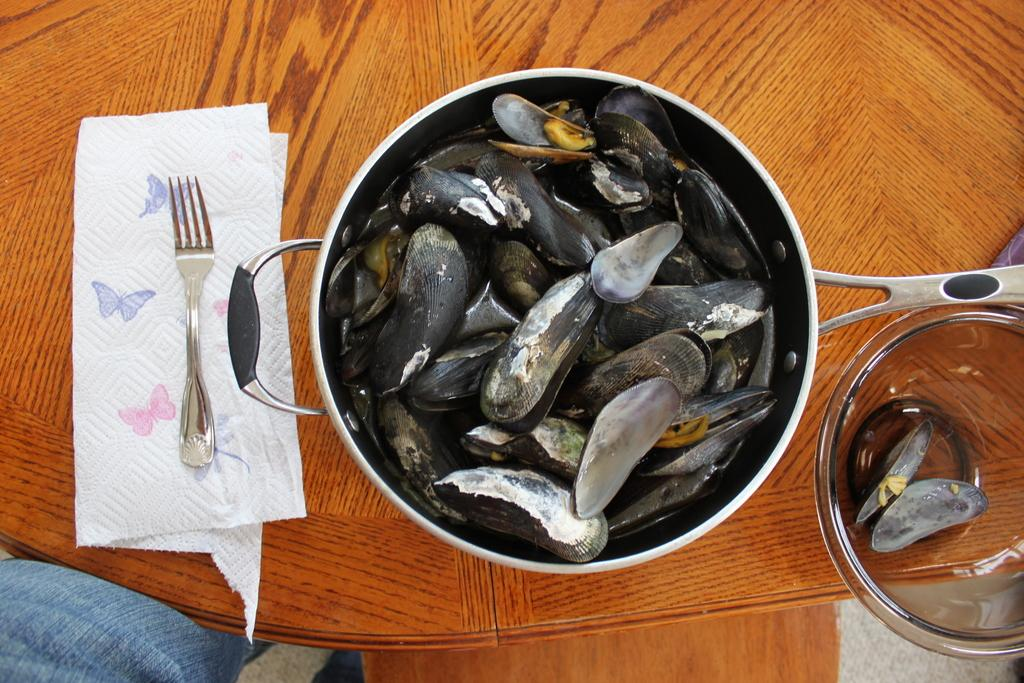What type of surface is visible in the image? There is a wooden surface in the image. What is placed on the wooden surface? There is a tissue on the wooden surface, and a fork is on the tissue. What else can be seen on the wooden surface? There is a pan with seashells and a bowl with shells on the wooden surface. How does the mother interact with the lip in the image? There is no mother or lip present in the image. 